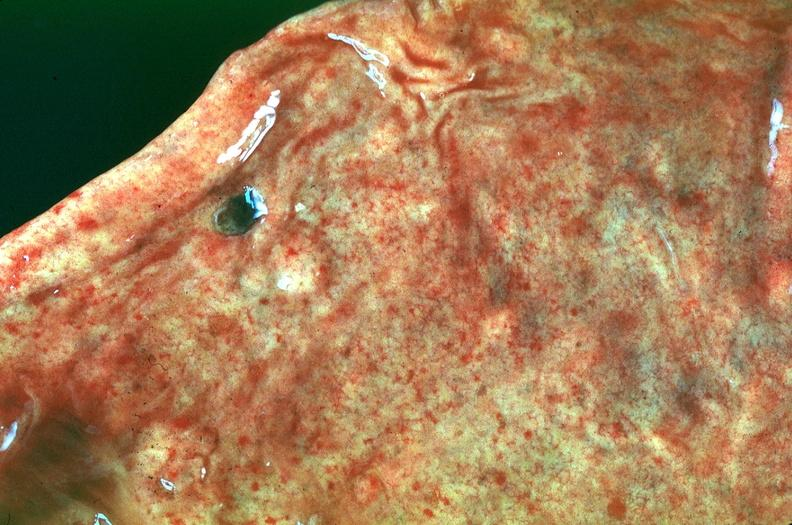what does this image show?
Answer the question using a single word or phrase. Stomach 